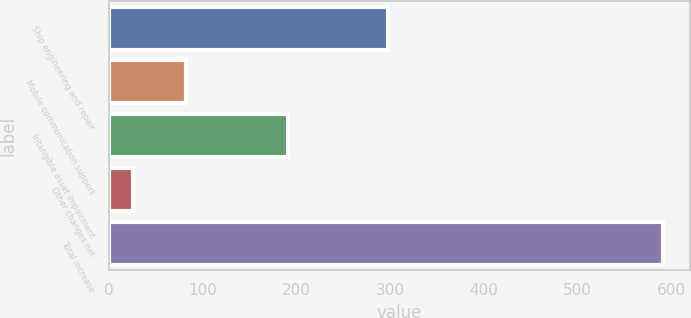Convert chart. <chart><loc_0><loc_0><loc_500><loc_500><bar_chart><fcel>Ship engineering and repair<fcel>Mobile communication support<fcel>Intangible asset impairment<fcel>Other changes net<fcel>Total increase<nl><fcel>298<fcel>82.5<fcel>191<fcel>26<fcel>591<nl></chart> 